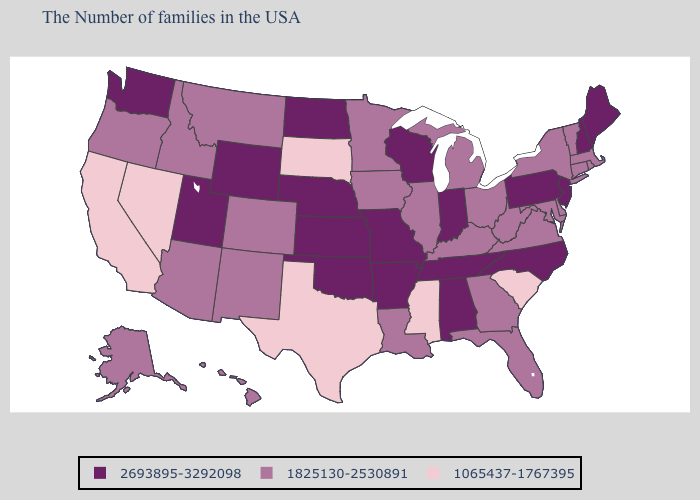Name the states that have a value in the range 2693895-3292098?
Short answer required. Maine, New Hampshire, New Jersey, Pennsylvania, North Carolina, Indiana, Alabama, Tennessee, Wisconsin, Missouri, Arkansas, Kansas, Nebraska, Oklahoma, North Dakota, Wyoming, Utah, Washington. Does Mississippi have the lowest value in the South?
Write a very short answer. Yes. What is the value of Hawaii?
Write a very short answer. 1825130-2530891. Name the states that have a value in the range 2693895-3292098?
Give a very brief answer. Maine, New Hampshire, New Jersey, Pennsylvania, North Carolina, Indiana, Alabama, Tennessee, Wisconsin, Missouri, Arkansas, Kansas, Nebraska, Oklahoma, North Dakota, Wyoming, Utah, Washington. Does the map have missing data?
Quick response, please. No. What is the highest value in states that border New York?
Keep it brief. 2693895-3292098. Does the first symbol in the legend represent the smallest category?
Write a very short answer. No. What is the value of Maryland?
Be succinct. 1825130-2530891. Does Delaware have the highest value in the USA?
Quick response, please. No. Name the states that have a value in the range 2693895-3292098?
Write a very short answer. Maine, New Hampshire, New Jersey, Pennsylvania, North Carolina, Indiana, Alabama, Tennessee, Wisconsin, Missouri, Arkansas, Kansas, Nebraska, Oklahoma, North Dakota, Wyoming, Utah, Washington. Does the first symbol in the legend represent the smallest category?
Quick response, please. No. Does Mississippi have a lower value than California?
Concise answer only. No. Does Nevada have the lowest value in the West?
Write a very short answer. Yes. Does Kansas have the highest value in the MidWest?
Be succinct. Yes. Which states hav the highest value in the MidWest?
Concise answer only. Indiana, Wisconsin, Missouri, Kansas, Nebraska, North Dakota. 